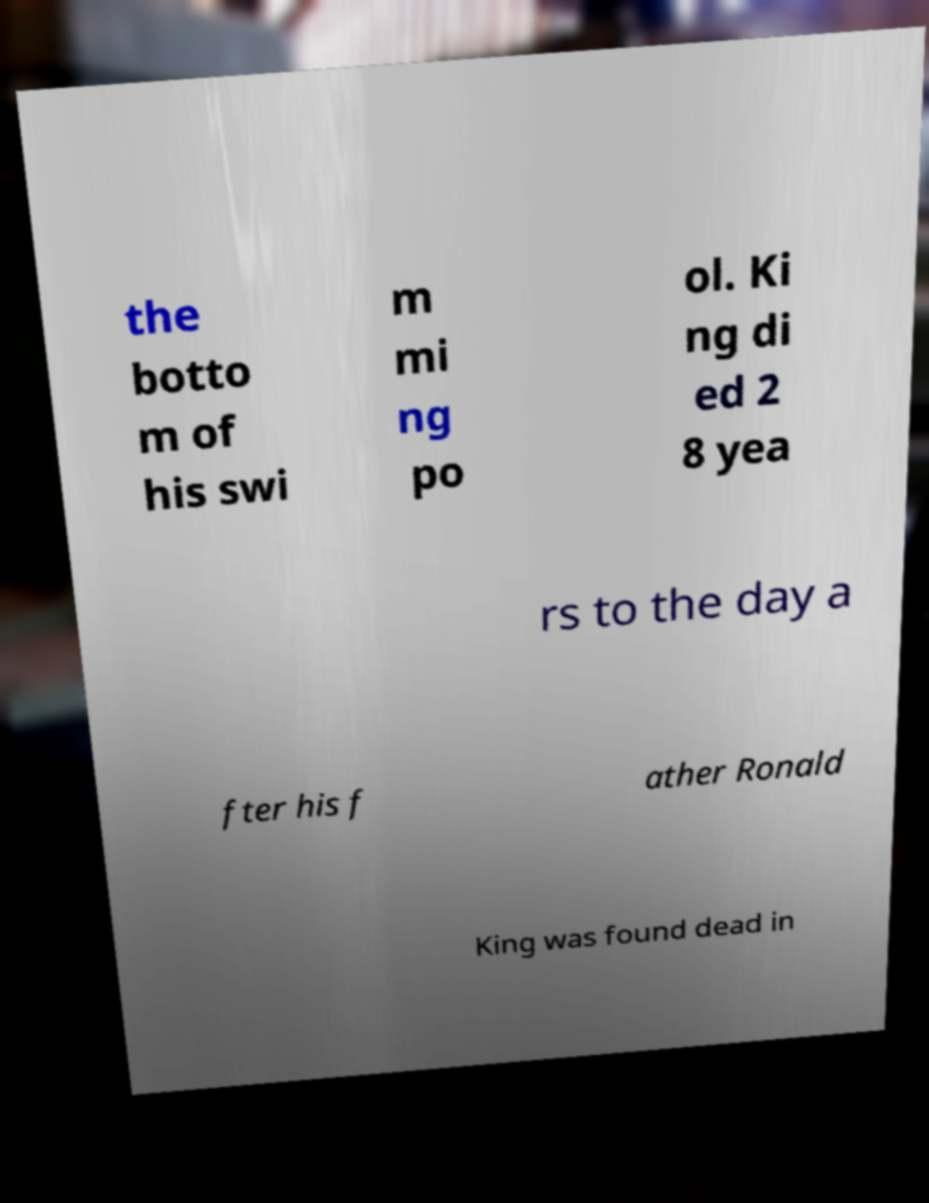For documentation purposes, I need the text within this image transcribed. Could you provide that? the botto m of his swi m mi ng po ol. Ki ng di ed 2 8 yea rs to the day a fter his f ather Ronald King was found dead in 